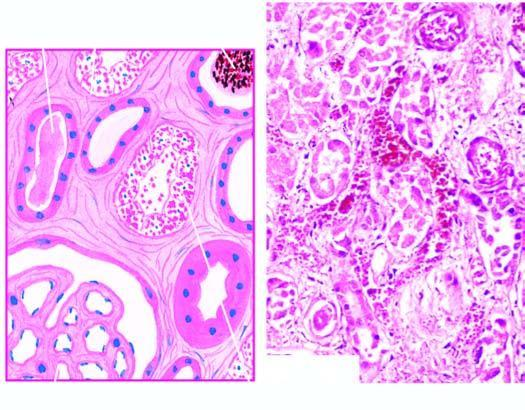what contain casts?
Answer the question using a single word or phrase. Lumina of affected tubules 